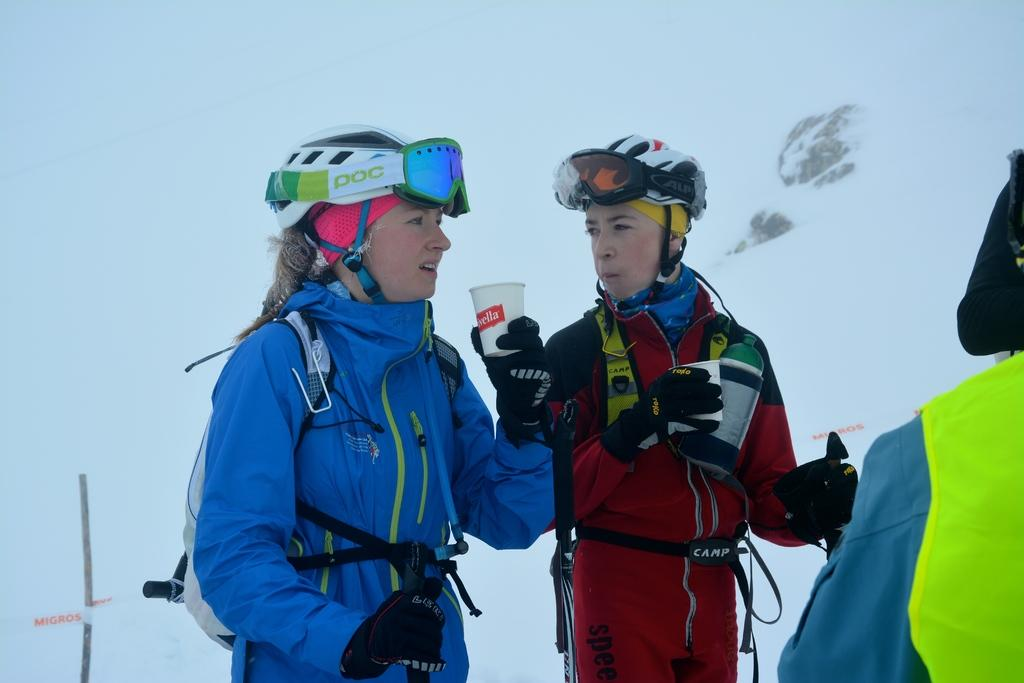How many people are in the image? There are people in the image. What are two people wearing in the image? Two people are wearing jackets, helmets, and goggles. What are the two people holding in the image? The two people are holding cups. What is the color of the background in the image? The background of the image is white. What objects can be seen in the image besides the people? Boards and a pole are visible in the image. What type of van can be seen in the scene in the image? There is no van present in the image; it features people wearing jackets, helmets, and goggles, holding cups, and standing near boards and a pole. What is the acoustics like in the image? The provided facts do not give any information about the acoustics in the image. 